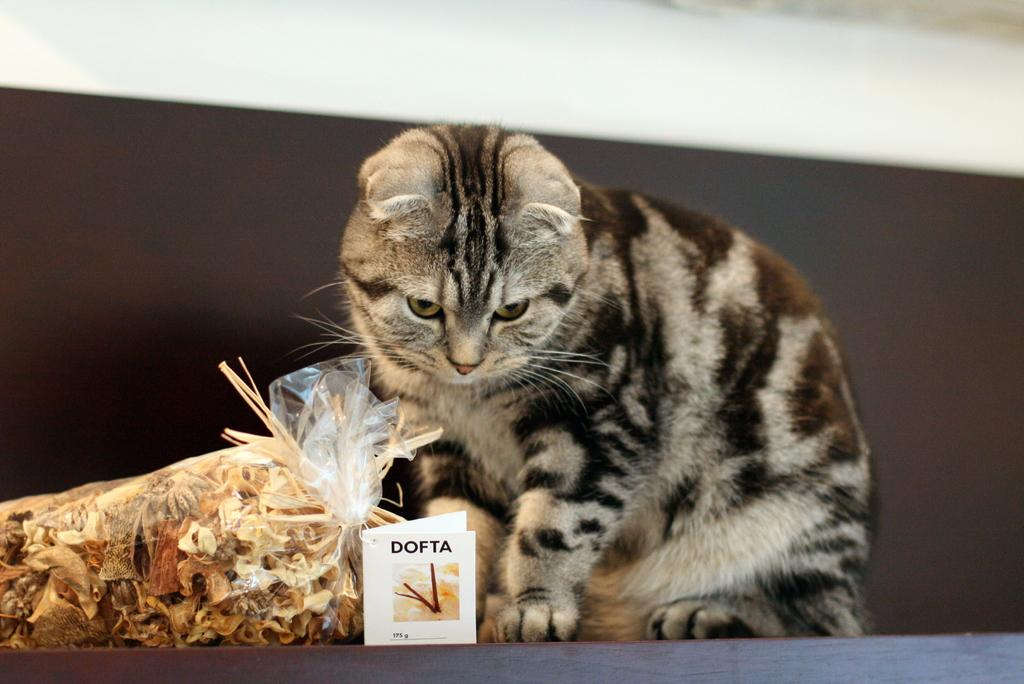What type of animal is present in the image? There is a cat in the image. What is located on the left side of the image? There is a cover on the left side of the image. What is visible at the bottom of the image? There is some paper at the bottom of the image. Where is the crib located in the image? There is no crib present in the image. What type of birth is depicted in the image? There is no birth depicted in the image; it features a cat, a cover, and some paper. 